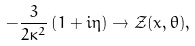Convert formula to latex. <formula><loc_0><loc_0><loc_500><loc_500>- \frac { 3 } { 2 \kappa ^ { 2 } } \left ( 1 + i \eta \right ) \rightarrow \mathcal { Z } ( x , \theta ) ,</formula> 